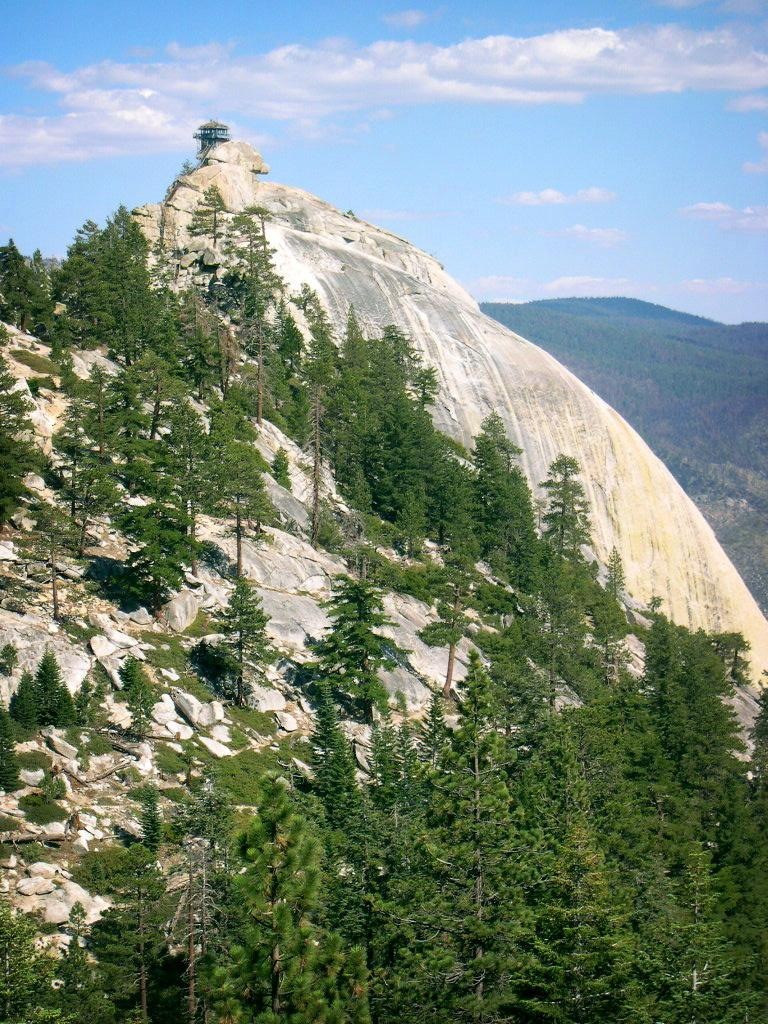What type of natural elements can be seen in the image? There are trees and hills in the image. What is located on top of one of the hills? There is a shelter on top of a hill in the image. What can be seen in the background of the image? The sky is visible in the background of the image. What type of amusement can be seen in the image? There is no amusement present in the image; it features trees, hills, and a shelter. What is the aftermath of the event in the image? There is no event or aftermath depicted in the image; it shows a natural landscape with a shelter on a hill. 